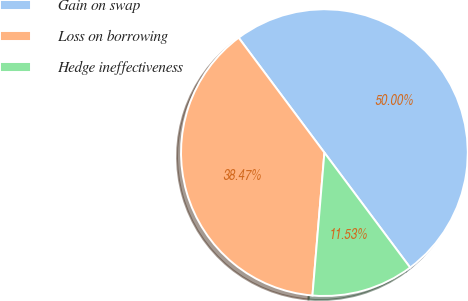Convert chart. <chart><loc_0><loc_0><loc_500><loc_500><pie_chart><fcel>Gain on swap<fcel>Loss on borrowing<fcel>Hedge ineffectiveness<nl><fcel>50.0%<fcel>38.47%<fcel>11.53%<nl></chart> 